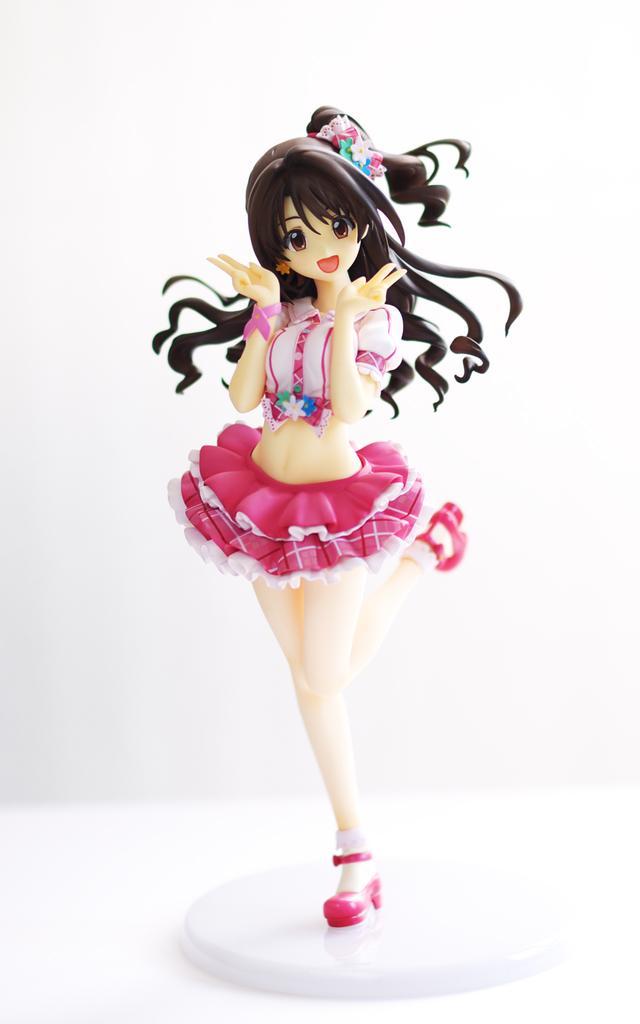How would you summarize this image in a sentence or two? In this picture I can see a doll and a white color background. 